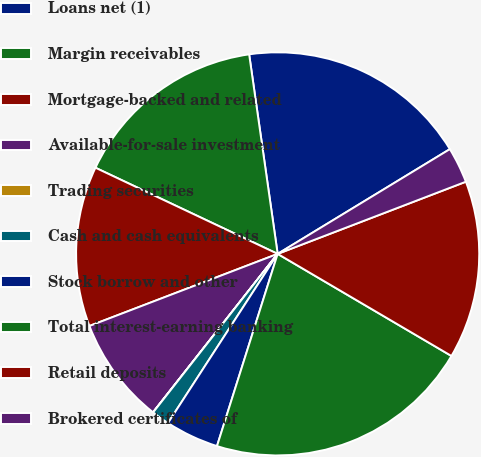<chart> <loc_0><loc_0><loc_500><loc_500><pie_chart><fcel>Loans net (1)<fcel>Margin receivables<fcel>Mortgage-backed and related<fcel>Available-for-sale investment<fcel>Trading securities<fcel>Cash and cash equivalents<fcel>Stock borrow and other<fcel>Total interest-earning banking<fcel>Retail deposits<fcel>Brokered certificates of<nl><fcel>18.56%<fcel>15.71%<fcel>12.85%<fcel>8.57%<fcel>0.01%<fcel>1.44%<fcel>4.29%<fcel>21.41%<fcel>14.28%<fcel>2.87%<nl></chart> 